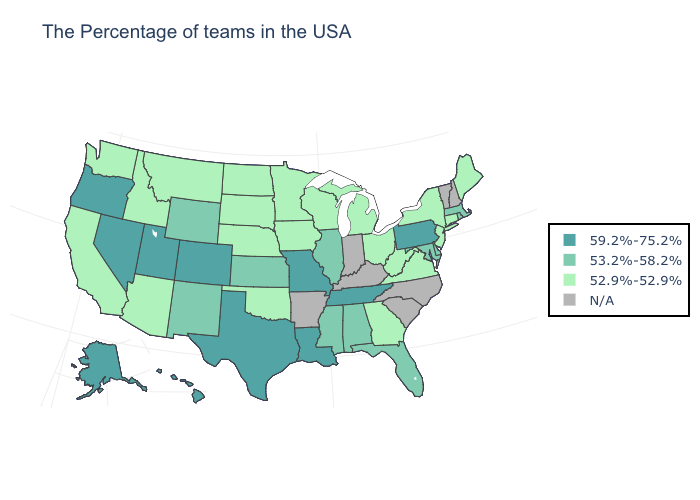Which states have the highest value in the USA?
Give a very brief answer. Pennsylvania, Tennessee, Louisiana, Missouri, Texas, Colorado, Utah, Nevada, Oregon, Alaska, Hawaii. What is the value of Hawaii?
Concise answer only. 59.2%-75.2%. What is the value of Hawaii?
Write a very short answer. 59.2%-75.2%. Does Georgia have the highest value in the USA?
Short answer required. No. What is the lowest value in states that border Colorado?
Short answer required. 52.9%-52.9%. Does the first symbol in the legend represent the smallest category?
Keep it brief. No. What is the highest value in states that border Tennessee?
Quick response, please. 59.2%-75.2%. Is the legend a continuous bar?
Keep it brief. No. How many symbols are there in the legend?
Concise answer only. 4. What is the value of Virginia?
Give a very brief answer. 52.9%-52.9%. What is the value of West Virginia?
Give a very brief answer. 52.9%-52.9%. What is the value of Indiana?
Concise answer only. N/A. Name the states that have a value in the range N/A?
Short answer required. New Hampshire, Vermont, North Carolina, South Carolina, Kentucky, Indiana, Arkansas. Which states have the lowest value in the USA?
Answer briefly. Maine, Connecticut, New York, New Jersey, Virginia, West Virginia, Ohio, Georgia, Michigan, Wisconsin, Minnesota, Iowa, Nebraska, Oklahoma, South Dakota, North Dakota, Montana, Arizona, Idaho, California, Washington. Is the legend a continuous bar?
Keep it brief. No. 